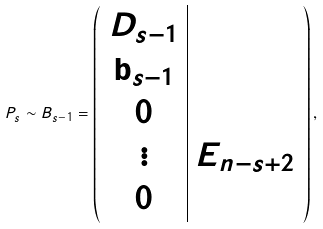Convert formula to latex. <formula><loc_0><loc_0><loc_500><loc_500>P _ { s } \sim B _ { s - 1 } = \left ( \begin{array} { c | c } D _ { s - 1 } & \\ \mathbf b _ { s - 1 } & \\ 0 & \\ \vdots & E _ { n - s + 2 } \\ 0 & \\ \end{array} \right ) ,</formula> 